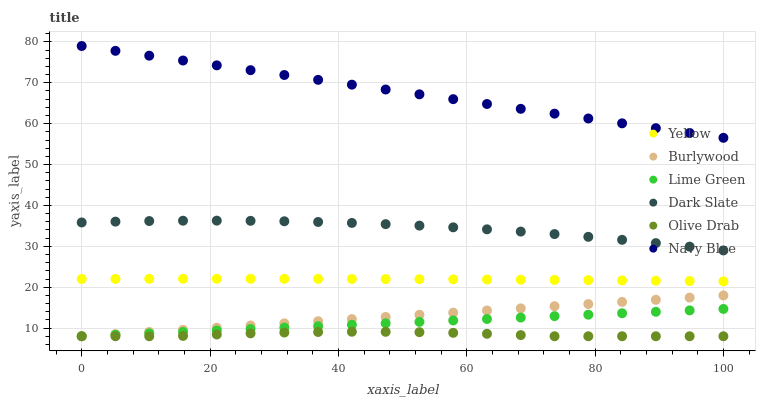Does Olive Drab have the minimum area under the curve?
Answer yes or no. Yes. Does Navy Blue have the maximum area under the curve?
Answer yes or no. Yes. Does Yellow have the minimum area under the curve?
Answer yes or no. No. Does Yellow have the maximum area under the curve?
Answer yes or no. No. Is Lime Green the smoothest?
Answer yes or no. Yes. Is Olive Drab the roughest?
Answer yes or no. Yes. Is Navy Blue the smoothest?
Answer yes or no. No. Is Navy Blue the roughest?
Answer yes or no. No. Does Burlywood have the lowest value?
Answer yes or no. Yes. Does Yellow have the lowest value?
Answer yes or no. No. Does Navy Blue have the highest value?
Answer yes or no. Yes. Does Yellow have the highest value?
Answer yes or no. No. Is Olive Drab less than Dark Slate?
Answer yes or no. Yes. Is Dark Slate greater than Olive Drab?
Answer yes or no. Yes. Does Burlywood intersect Lime Green?
Answer yes or no. Yes. Is Burlywood less than Lime Green?
Answer yes or no. No. Is Burlywood greater than Lime Green?
Answer yes or no. No. Does Olive Drab intersect Dark Slate?
Answer yes or no. No. 